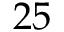Convert formula to latex. <formula><loc_0><loc_0><loc_500><loc_500>2 5</formula> 